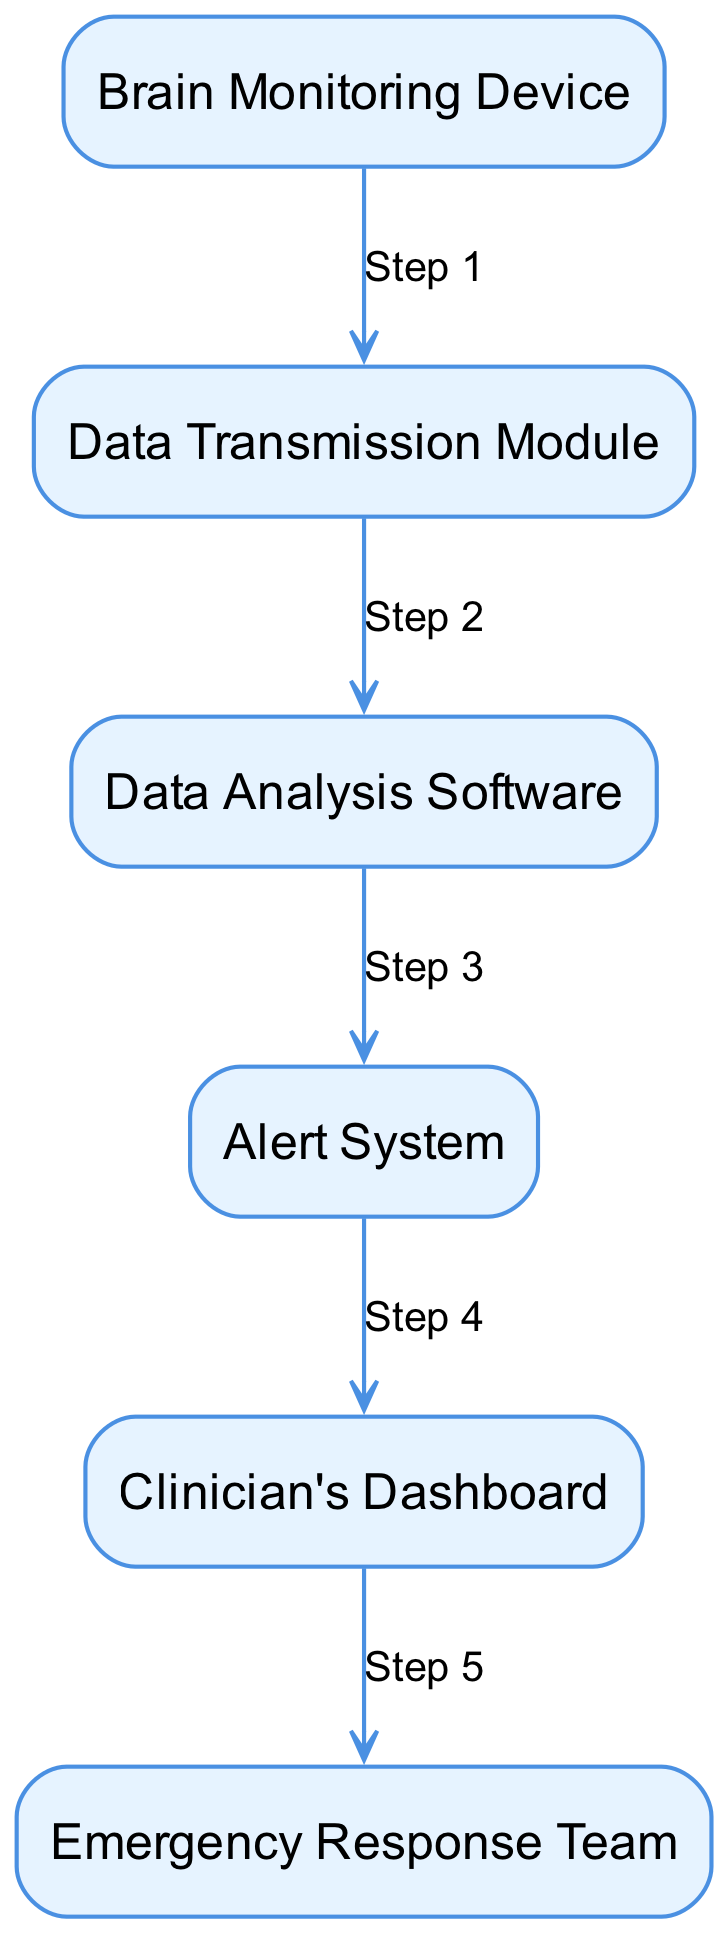What is the first element in the diagram? The first element in the diagram is "Brain Monitoring Device," which is listed as the starting point of the communication workflow.
Answer: Brain Monitoring Device How many nodes are present in the diagram? The diagram includes six nodes, each representing a distinct element in the communication workflow.
Answer: 6 What step follows the "Data Analysis Software"? The step that follows "Data Analysis Software" is "Alert System," indicating that alerts are generated after data analysis.
Answer: Alert System Which element generates alerts based on analysis results? The "Alert System" is the element responsible for generating alerts, as specified in the workflow.
Answer: Alert System What is the last element in the communication workflow? The last element in the diagram is the "Emergency Response Team," indicating the final step in the communication process.
Answer: Emergency Response Team What relationship exists between the "Data Transmission Module" and "Data Analysis Software"? The relationship is that the "Data Transmission Module" sends the data to the "Data Analysis Software" for analysis, reflecting the flow of information.
Answer: Data Transmission Which element's description mentions "wearable device"? The description of the "Brain Monitoring Device" mentions it is a wearable device that detects and records brain activity.
Answer: Brain Monitoring Device How many steps are shown between the "Brain Monitoring Device" and the "Clinician's Dashboard"? There are four steps shown in the workflow from the "Brain Monitoring Device" to the "Clinician's Dashboard," connecting various elements in between.
Answer: 4 Which element does the "Alert System" directly notify? The "Alert System" directly notifies the "Clinician's Dashboard," where clinicians receive alerts and view patient data.
Answer: Clinician's Dashboard 